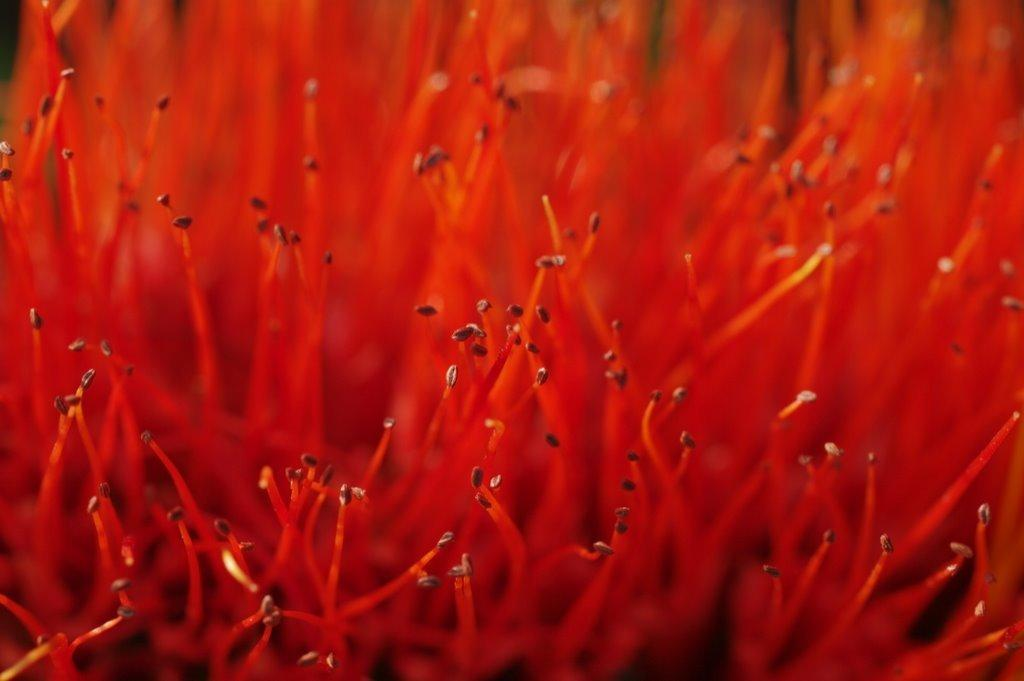What is present in the image? There is pollen in the image. Can you describe the pollen in the image? The pollen is red in color. What type of lumber is being used to build the square structure in the image? There is no lumber or square structure present in the image; it only features pollen. How many beans are visible in the image? There are no beans present in the image; it only features pollen. 